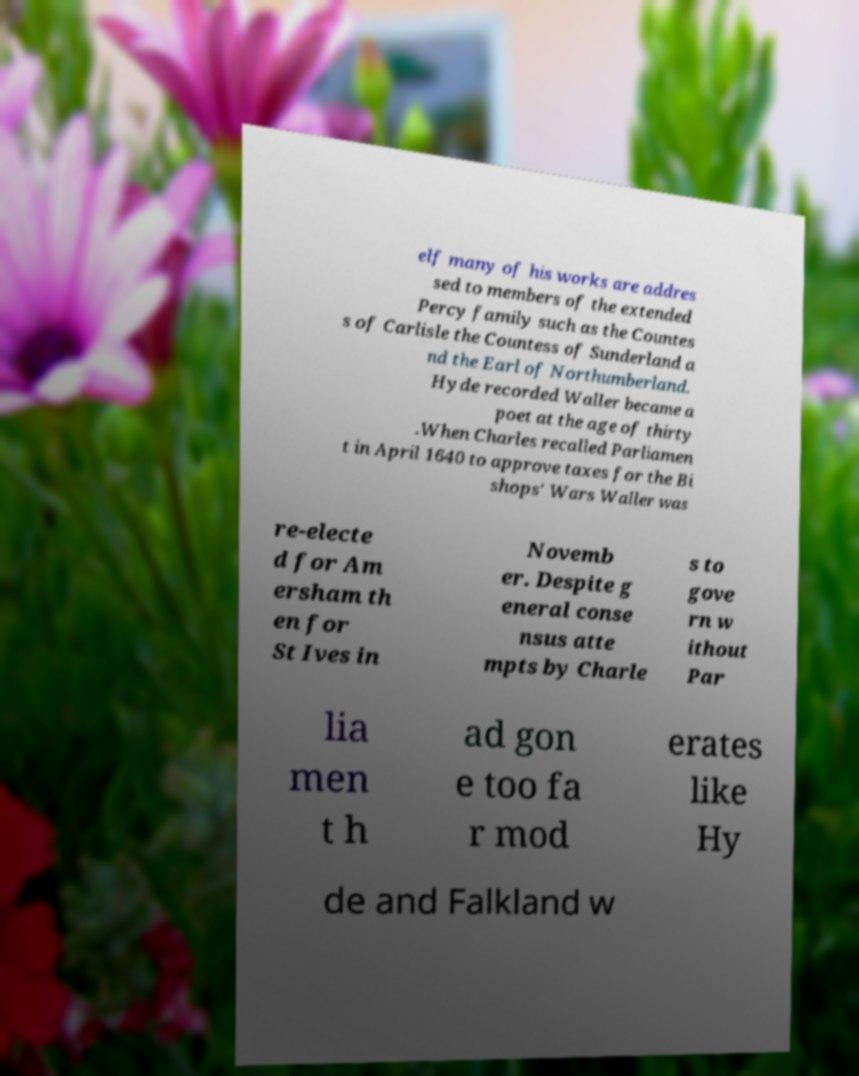Please identify and transcribe the text found in this image. elf many of his works are addres sed to members of the extended Percy family such as the Countes s of Carlisle the Countess of Sunderland a nd the Earl of Northumberland. Hyde recorded Waller became a poet at the age of thirty .When Charles recalled Parliamen t in April 1640 to approve taxes for the Bi shops' Wars Waller was re-electe d for Am ersham th en for St Ives in Novemb er. Despite g eneral conse nsus atte mpts by Charle s to gove rn w ithout Par lia men t h ad gon e too fa r mod erates like Hy de and Falkland w 